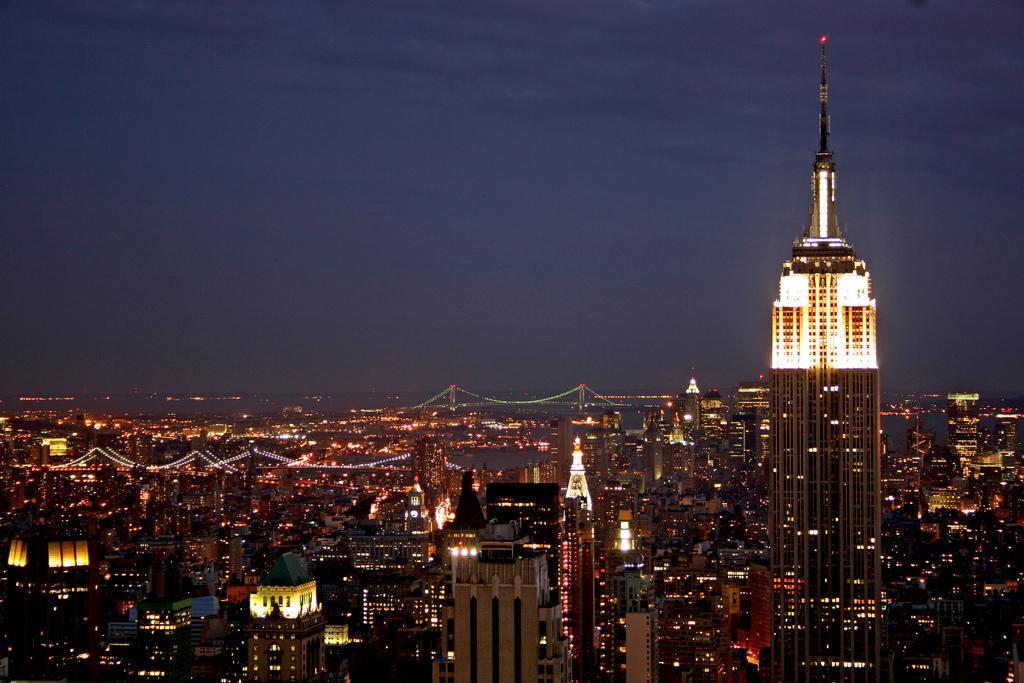How would you summarize this image in a sentence or two? In this image I can see number of buildings, few lights to the buildings, few bridges and the water. In the background I can see the sky. 